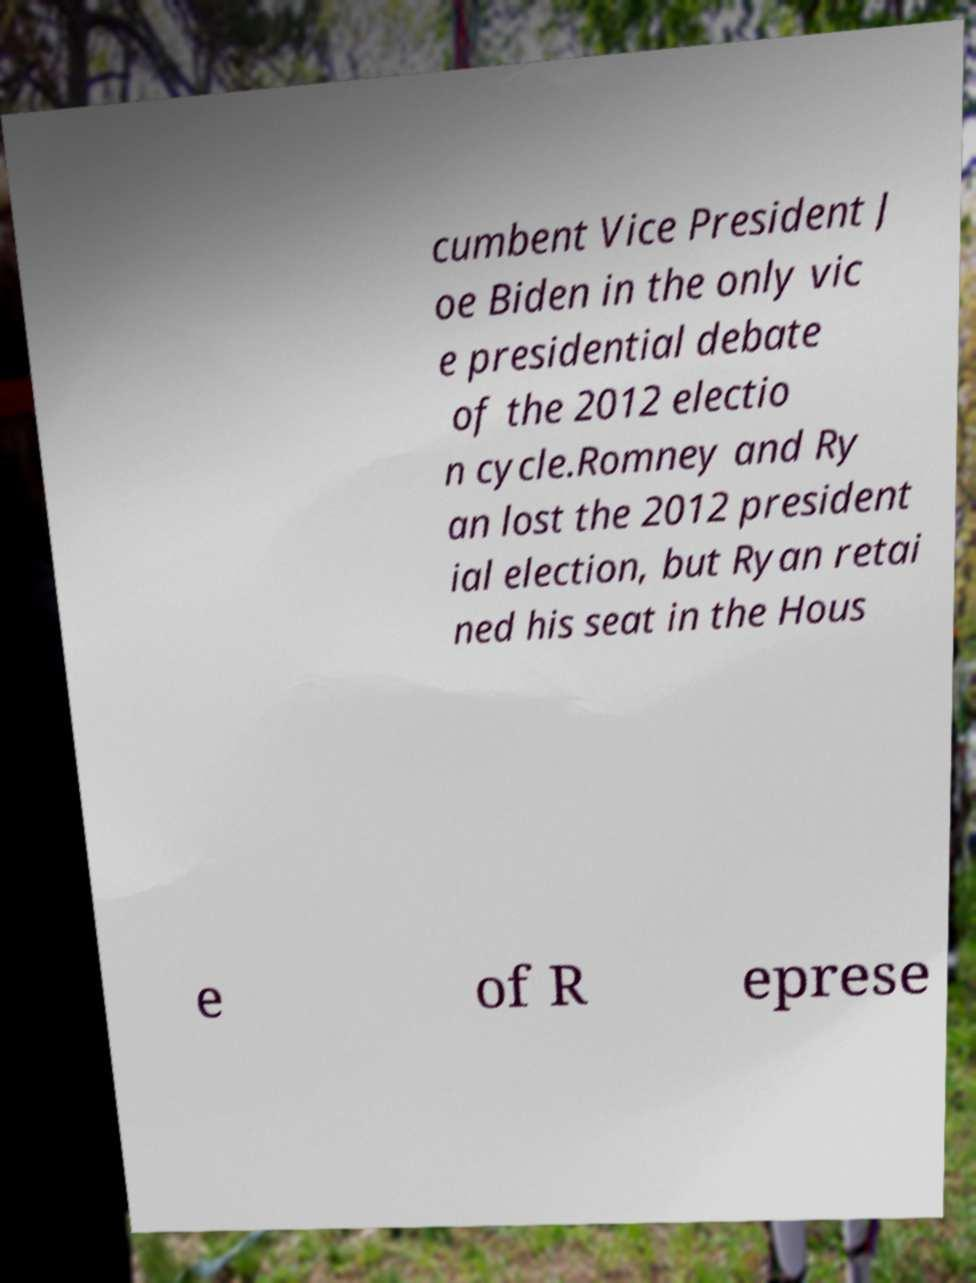Please identify and transcribe the text found in this image. cumbent Vice President J oe Biden in the only vic e presidential debate of the 2012 electio n cycle.Romney and Ry an lost the 2012 president ial election, but Ryan retai ned his seat in the Hous e of R eprese 